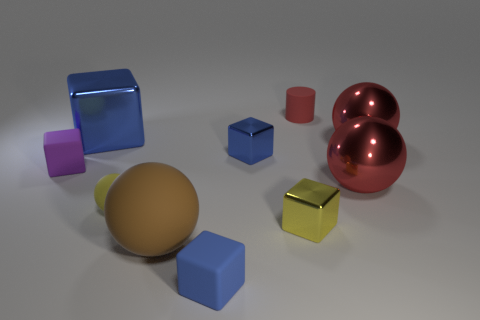Subtract all brown spheres. How many blue blocks are left? 3 Subtract all red blocks. Subtract all brown cylinders. How many blocks are left? 5 Subtract all balls. How many objects are left? 6 Subtract 1 brown spheres. How many objects are left? 9 Subtract all tiny yellow shiny objects. Subtract all purple blocks. How many objects are left? 8 Add 4 small spheres. How many small spheres are left? 5 Add 9 tiny red rubber cylinders. How many tiny red rubber cylinders exist? 10 